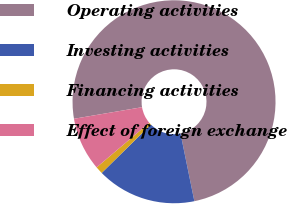<chart> <loc_0><loc_0><loc_500><loc_500><pie_chart><fcel>Operating activities<fcel>Investing activities<fcel>Financing activities<fcel>Effect of foreign exchange<nl><fcel>74.48%<fcel>15.84%<fcel>1.18%<fcel>8.51%<nl></chart> 